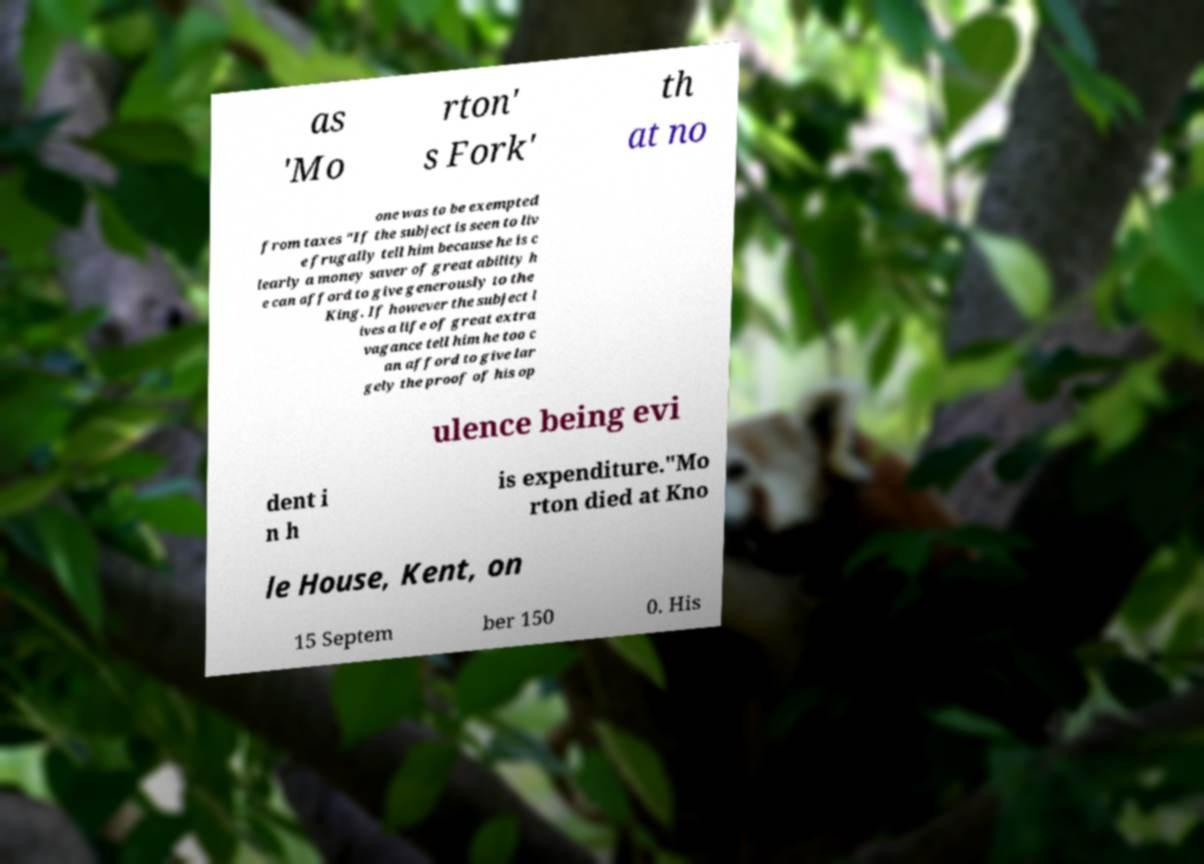Please identify and transcribe the text found in this image. as 'Mo rton' s Fork' th at no one was to be exempted from taxes "If the subject is seen to liv e frugally tell him because he is c learly a money saver of great ability h e can afford to give generously to the King. If however the subject l ives a life of great extra vagance tell him he too c an afford to give lar gely the proof of his op ulence being evi dent i n h is expenditure."Mo rton died at Kno le House, Kent, on 15 Septem ber 150 0. His 